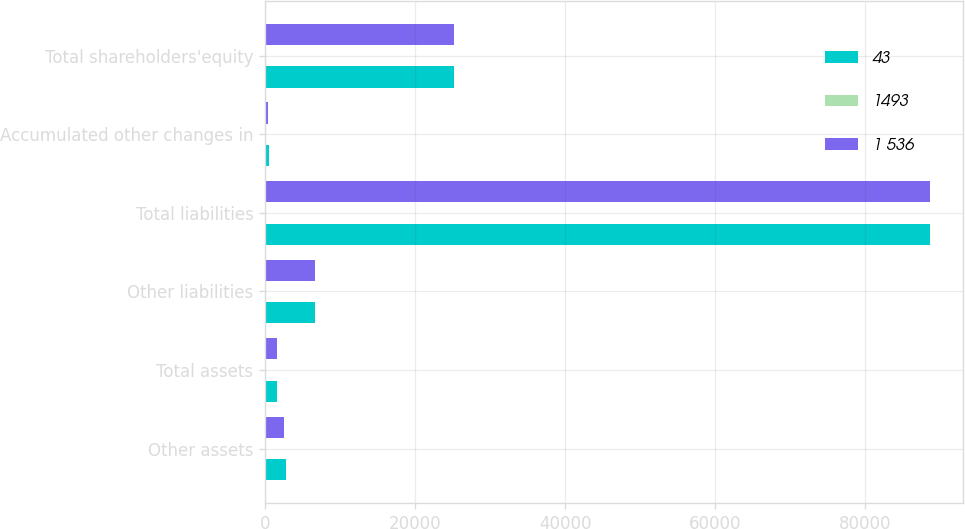Convert chart. <chart><loc_0><loc_0><loc_500><loc_500><stacked_bar_chart><ecel><fcel>Other assets<fcel>Total assets<fcel>Other liabilities<fcel>Total liabilities<fcel>Accumulated other changes in<fcel>Total shareholders'equity<nl><fcel>43<fcel>2742<fcel>1559.5<fcel>6674<fcel>88658<fcel>532<fcel>25215<nl><fcel>1493<fcel>155<fcel>112<fcel>32<fcel>32<fcel>80<fcel>80<nl><fcel>1 536<fcel>2587<fcel>1559.5<fcel>6642<fcel>88626<fcel>452<fcel>25135<nl></chart> 